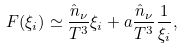Convert formula to latex. <formula><loc_0><loc_0><loc_500><loc_500>F ( \xi _ { i } ) \simeq \frac { \hat { n } _ { \nu } } { T ^ { 3 } } \xi _ { i } + a \frac { \hat { n } _ { \nu } } { T ^ { 3 } } \frac { 1 } { \xi _ { i } } ,</formula> 